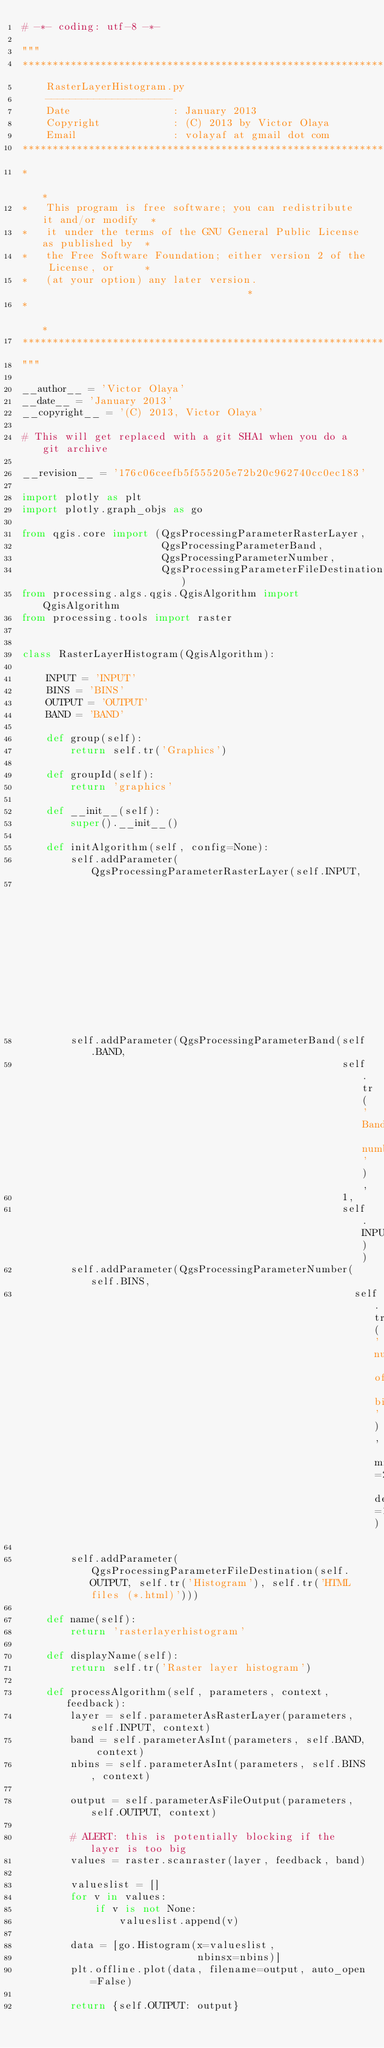Convert code to text. <code><loc_0><loc_0><loc_500><loc_500><_Python_># -*- coding: utf-8 -*-

"""
***************************************************************************
    RasterLayerHistogram.py
    ---------------------
    Date                 : January 2013
    Copyright            : (C) 2013 by Victor Olaya
    Email                : volayaf at gmail dot com
***************************************************************************
*                                                                         *
*   This program is free software; you can redistribute it and/or modify  *
*   it under the terms of the GNU General Public License as published by  *
*   the Free Software Foundation; either version 2 of the License, or     *
*   (at your option) any later version.                                   *
*                                                                         *
***************************************************************************
"""

__author__ = 'Victor Olaya'
__date__ = 'January 2013'
__copyright__ = '(C) 2013, Victor Olaya'

# This will get replaced with a git SHA1 when you do a git archive

__revision__ = '176c06ceefb5f555205e72b20c962740cc0ec183'

import plotly as plt
import plotly.graph_objs as go

from qgis.core import (QgsProcessingParameterRasterLayer,
                       QgsProcessingParameterBand,
                       QgsProcessingParameterNumber,
                       QgsProcessingParameterFileDestination)
from processing.algs.qgis.QgisAlgorithm import QgisAlgorithm
from processing.tools import raster


class RasterLayerHistogram(QgisAlgorithm):

    INPUT = 'INPUT'
    BINS = 'BINS'
    OUTPUT = 'OUTPUT'
    BAND = 'BAND'

    def group(self):
        return self.tr('Graphics')

    def groupId(self):
        return 'graphics'

    def __init__(self):
        super().__init__()

    def initAlgorithm(self, config=None):
        self.addParameter(QgsProcessingParameterRasterLayer(self.INPUT,
                                                            self.tr('Input layer')))
        self.addParameter(QgsProcessingParameterBand(self.BAND,
                                                     self.tr('Band number'),
                                                     1,
                                                     self.INPUT))
        self.addParameter(QgsProcessingParameterNumber(self.BINS,
                                                       self.tr('number of bins'), minValue=2, defaultValue=10))

        self.addParameter(QgsProcessingParameterFileDestination(self.OUTPUT, self.tr('Histogram'), self.tr('HTML files (*.html)')))

    def name(self):
        return 'rasterlayerhistogram'

    def displayName(self):
        return self.tr('Raster layer histogram')

    def processAlgorithm(self, parameters, context, feedback):
        layer = self.parameterAsRasterLayer(parameters, self.INPUT, context)
        band = self.parameterAsInt(parameters, self.BAND, context)
        nbins = self.parameterAsInt(parameters, self.BINS, context)

        output = self.parameterAsFileOutput(parameters, self.OUTPUT, context)

        # ALERT: this is potentially blocking if the layer is too big
        values = raster.scanraster(layer, feedback, band)

        valueslist = []
        for v in values:
            if v is not None:
                valueslist.append(v)

        data = [go.Histogram(x=valueslist,
                             nbinsx=nbins)]
        plt.offline.plot(data, filename=output, auto_open=False)

        return {self.OUTPUT: output}
</code> 